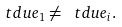Convert formula to latex. <formula><loc_0><loc_0><loc_500><loc_500>\ t d u e _ { 1 } \neq \ t d u e _ { i } .</formula> 